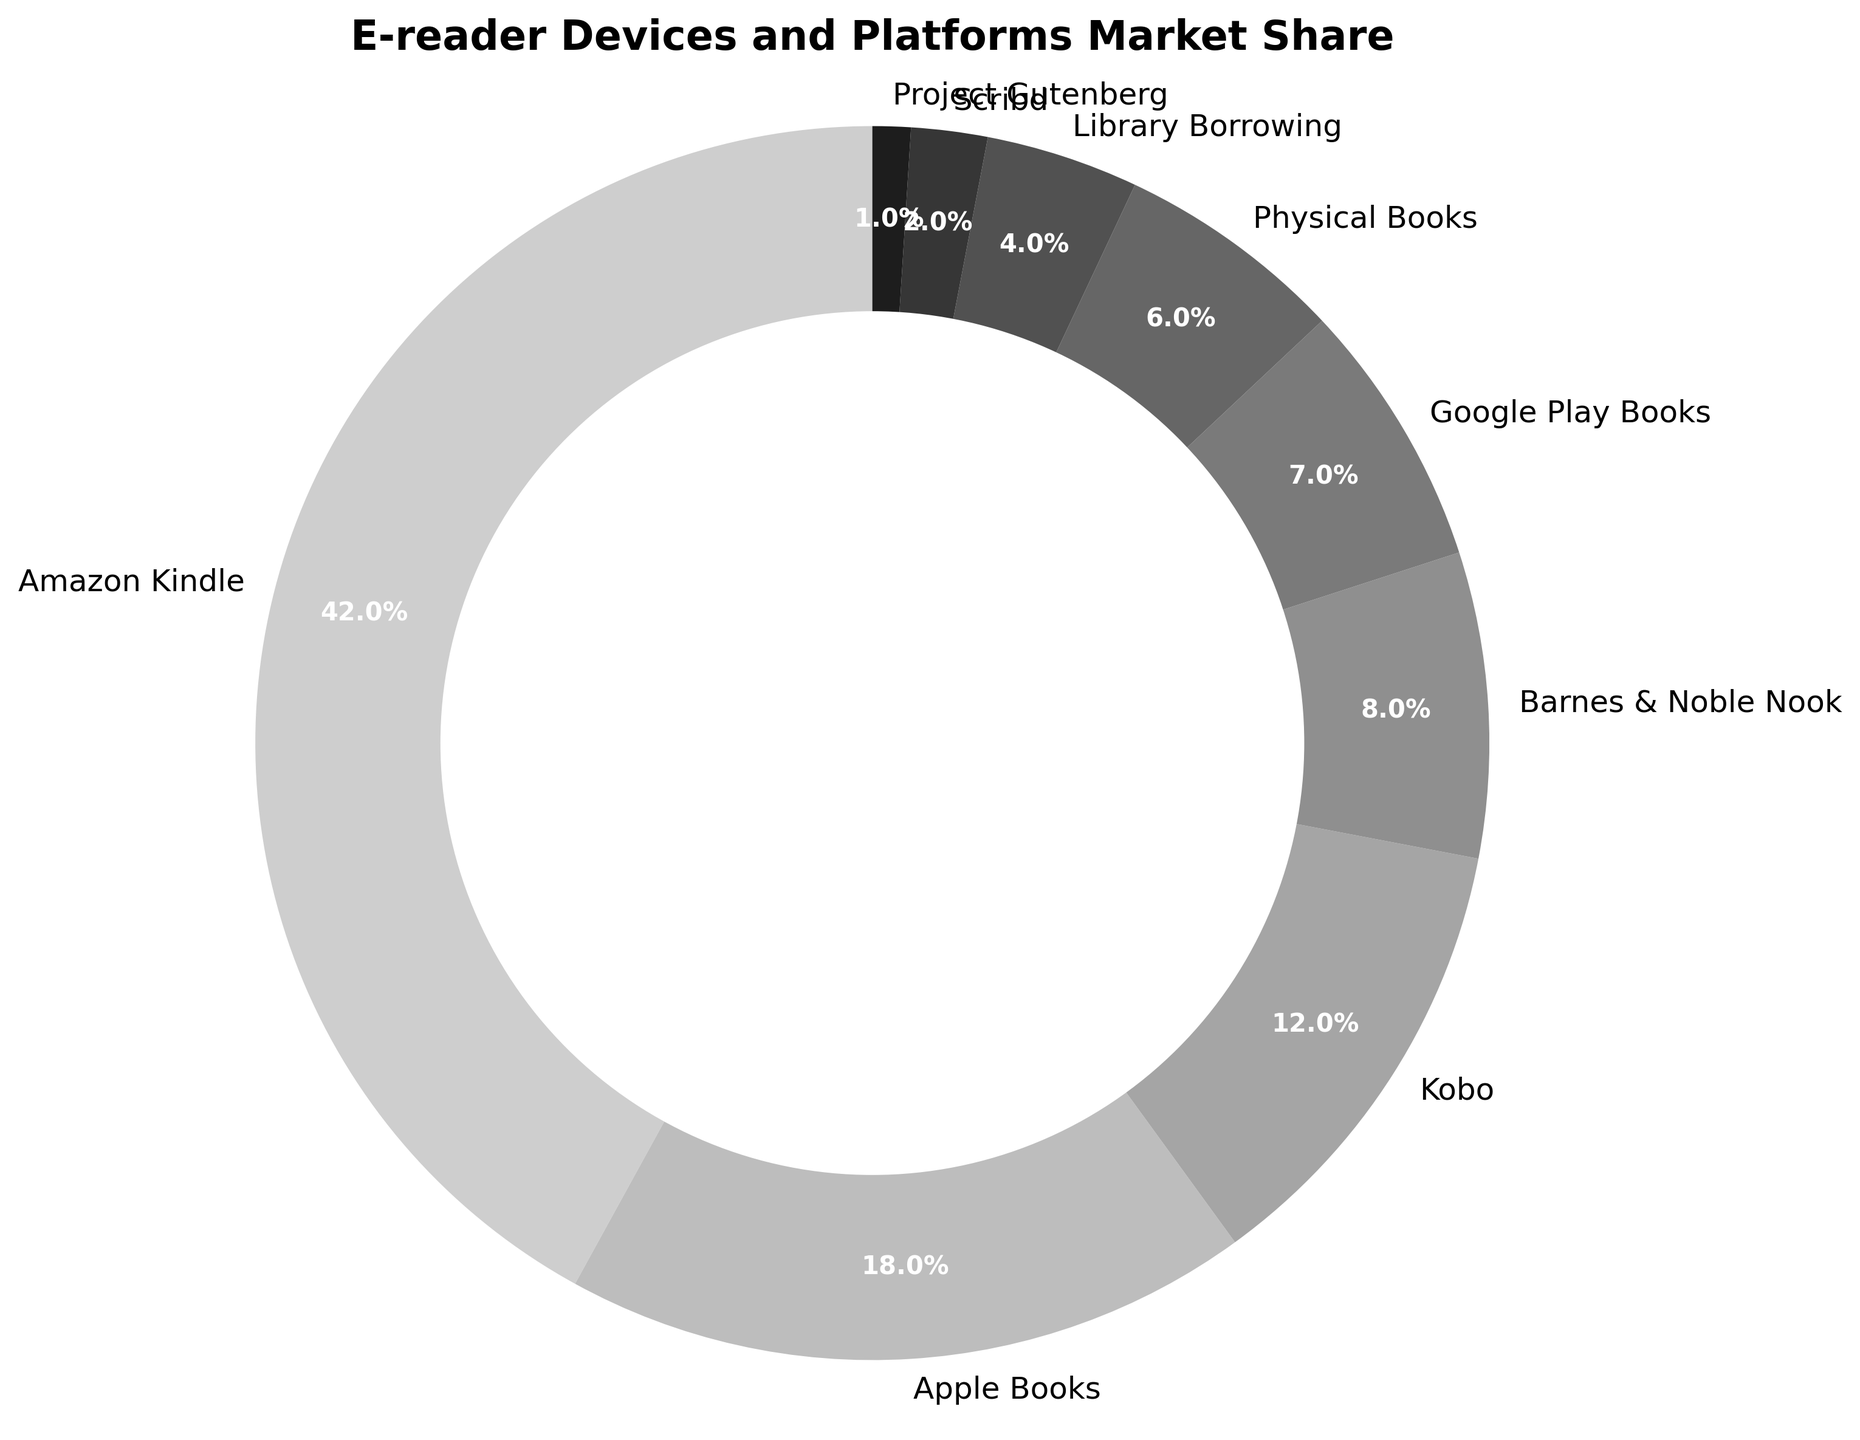What's the most popular e-reader device or platform? The pie chart's largest section indicates the most popular e-reader device or platform. Amazon Kindle has the largest section, making it the most popular with a 42% market share.
Answer: Amazon Kindle Which e-reader device or platform has the smallest market share? The pie chart's smallest section indicates the e-reader device or platform with the smallest market share. Project Gutenberg, which has a 1% market share, is the smallest.
Answer: Project Gutenberg How much larger is the market share of Amazon Kindle compared to Barnes & Noble Nook? To find the difference in market share between Amazon Kindle and Barnes & Noble Nook, subtract Nook's market share from Kindle's market share: 42% - 8% = 34%.
Answer: 34% What is the combined market share of Apple Books and Google Play Books? To calculate the combined market share of Apple Books and Google Play Books, add their individual market shares together: 18% + 7% = 25%.
Answer: 25% Which has a greater market share, Kobo or Library Borrowing? To determine which has a greater market share, compare the values directly from the pie chart. Kobo has a 12% market share, whereas Library Borrowing has a 4% market share, so Kobo is greater.
Answer: Kobo Are there any e-reader platforms with a market share less than 5%? To find if any e-reader platforms have a market share less than 5%, look for sections of the pie chart that represent smaller percentages. Scribd (2%) and Project Gutenberg (1%) both have market shares less than 5%.
Answer: Yes What is the total market share of platforms other than Amazon Kindle? Subtract Kindle's market share from the total (100%) to find the market share of all other platforms: 100% - 42% = 58%.
Answer: 58% What percentage of the market is captured by digital platforms (all platforms excluding Physical Books and Library Borrowing)? Sum the market shares of Amazon Kindle, Apple Books, Kobo, Barnes & Noble Nook, Google Play Books, Scribd, and Project Gutenberg: 42% + 18% + 12% + 8% + 7% + 2% + 1% = 90%.
Answer: 90% How does the combined market share of Physical Books and Library Borrowing compare to the market share of Kobo? Add the market shares of Physical Books and Library Borrowing: 6% + 4% = 10%. Since Kobo's market share is 12%, Kobo has a higher market share.
Answer: Kobo's is higher What is the ratio of Amazon Kindle's market share to Google Play Books' market share? To find the ratio, divide Amazon Kindle's market share by Google Play Books' market share: 42 / 7 = 6.
Answer: 6:1 